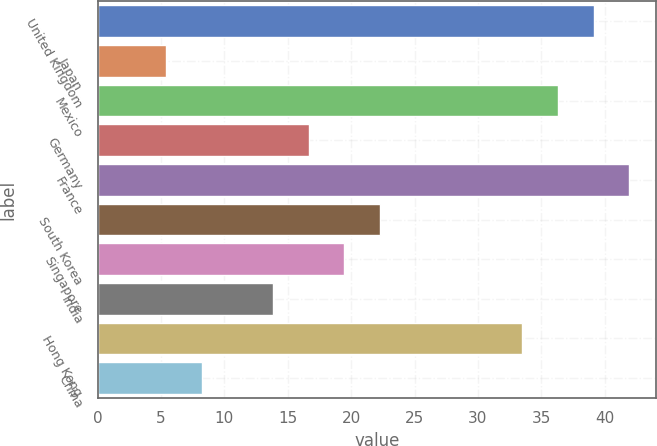Convert chart. <chart><loc_0><loc_0><loc_500><loc_500><bar_chart><fcel>United Kingdom<fcel>Japan<fcel>Mexico<fcel>Germany<fcel>France<fcel>South Korea<fcel>Singapore<fcel>India<fcel>Hong Kong<fcel>China<nl><fcel>39.13<fcel>5.41<fcel>36.32<fcel>16.65<fcel>41.94<fcel>22.27<fcel>19.46<fcel>13.84<fcel>33.51<fcel>8.22<nl></chart> 